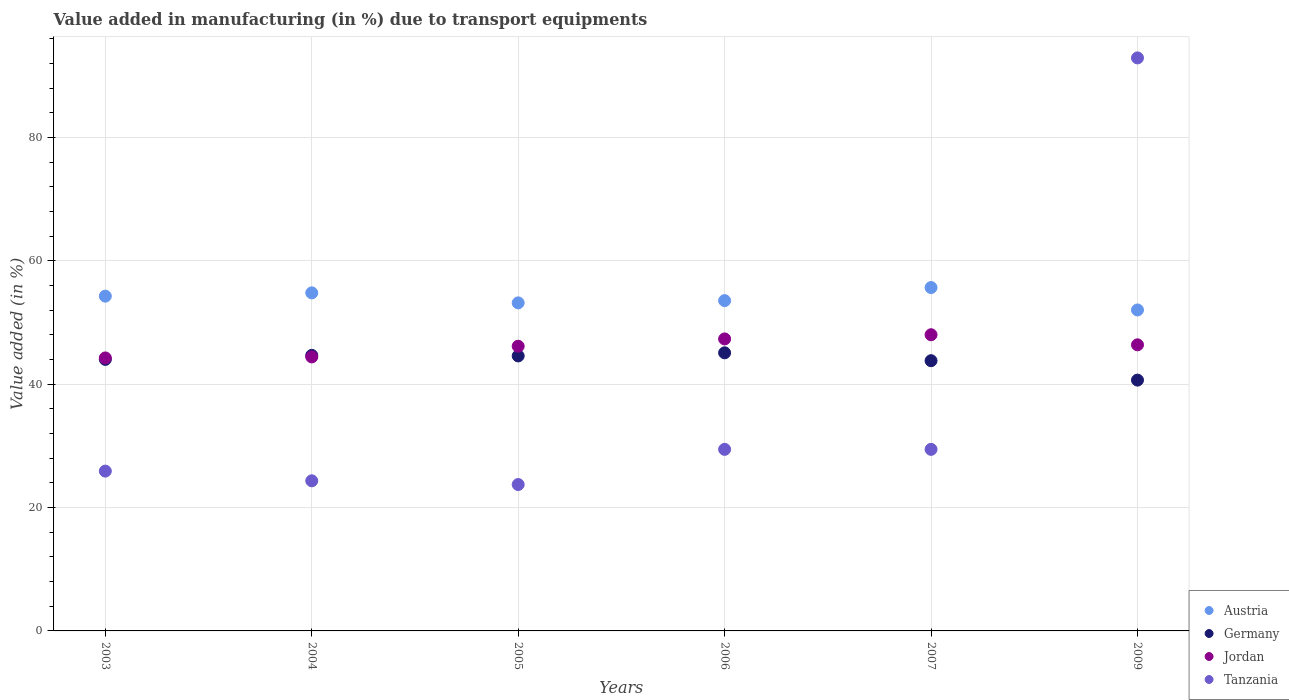What is the percentage of value added in manufacturing due to transport equipments in Germany in 2009?
Your answer should be compact. 40.67. Across all years, what is the maximum percentage of value added in manufacturing due to transport equipments in Austria?
Keep it short and to the point. 55.69. Across all years, what is the minimum percentage of value added in manufacturing due to transport equipments in Austria?
Your answer should be very brief. 52.05. What is the total percentage of value added in manufacturing due to transport equipments in Germany in the graph?
Keep it short and to the point. 262.91. What is the difference between the percentage of value added in manufacturing due to transport equipments in Jordan in 2007 and that in 2009?
Your answer should be very brief. 1.63. What is the difference between the percentage of value added in manufacturing due to transport equipments in Tanzania in 2006 and the percentage of value added in manufacturing due to transport equipments in Germany in 2004?
Provide a succinct answer. -15.24. What is the average percentage of value added in manufacturing due to transport equipments in Austria per year?
Make the answer very short. 53.94. In the year 2006, what is the difference between the percentage of value added in manufacturing due to transport equipments in Germany and percentage of value added in manufacturing due to transport equipments in Tanzania?
Give a very brief answer. 15.66. In how many years, is the percentage of value added in manufacturing due to transport equipments in Germany greater than 84 %?
Ensure brevity in your answer.  0. What is the ratio of the percentage of value added in manufacturing due to transport equipments in Jordan in 2005 to that in 2009?
Provide a succinct answer. 1. Is the percentage of value added in manufacturing due to transport equipments in Jordan in 2003 less than that in 2004?
Provide a succinct answer. Yes. What is the difference between the highest and the second highest percentage of value added in manufacturing due to transport equipments in Tanzania?
Make the answer very short. 63.48. What is the difference between the highest and the lowest percentage of value added in manufacturing due to transport equipments in Tanzania?
Provide a short and direct response. 69.19. Is the percentage of value added in manufacturing due to transport equipments in Tanzania strictly greater than the percentage of value added in manufacturing due to transport equipments in Jordan over the years?
Provide a short and direct response. No. Is the percentage of value added in manufacturing due to transport equipments in Jordan strictly less than the percentage of value added in manufacturing due to transport equipments in Austria over the years?
Your answer should be compact. Yes. How many dotlines are there?
Provide a short and direct response. 4. What is the difference between two consecutive major ticks on the Y-axis?
Your answer should be very brief. 20. Does the graph contain any zero values?
Offer a terse response. No. Does the graph contain grids?
Provide a succinct answer. Yes. Where does the legend appear in the graph?
Offer a very short reply. Bottom right. How are the legend labels stacked?
Make the answer very short. Vertical. What is the title of the graph?
Offer a terse response. Value added in manufacturing (in %) due to transport equipments. Does "Panama" appear as one of the legend labels in the graph?
Make the answer very short. No. What is the label or title of the X-axis?
Keep it short and to the point. Years. What is the label or title of the Y-axis?
Your answer should be very brief. Value added (in %). What is the Value added (in %) of Austria in 2003?
Offer a terse response. 54.29. What is the Value added (in %) of Germany in 2003?
Your answer should be very brief. 44.03. What is the Value added (in %) in Jordan in 2003?
Your answer should be very brief. 44.27. What is the Value added (in %) in Tanzania in 2003?
Keep it short and to the point. 25.92. What is the Value added (in %) of Austria in 2004?
Provide a succinct answer. 54.82. What is the Value added (in %) of Germany in 2004?
Provide a succinct answer. 44.69. What is the Value added (in %) in Jordan in 2004?
Ensure brevity in your answer.  44.44. What is the Value added (in %) in Tanzania in 2004?
Ensure brevity in your answer.  24.34. What is the Value added (in %) in Austria in 2005?
Your response must be concise. 53.2. What is the Value added (in %) of Germany in 2005?
Offer a very short reply. 44.6. What is the Value added (in %) in Jordan in 2005?
Your response must be concise. 46.17. What is the Value added (in %) of Tanzania in 2005?
Make the answer very short. 23.74. What is the Value added (in %) in Austria in 2006?
Your answer should be very brief. 53.56. What is the Value added (in %) of Germany in 2006?
Your answer should be compact. 45.1. What is the Value added (in %) of Jordan in 2006?
Your answer should be compact. 47.35. What is the Value added (in %) of Tanzania in 2006?
Offer a terse response. 29.44. What is the Value added (in %) of Austria in 2007?
Your answer should be very brief. 55.69. What is the Value added (in %) in Germany in 2007?
Offer a very short reply. 43.82. What is the Value added (in %) of Jordan in 2007?
Your response must be concise. 48.03. What is the Value added (in %) in Tanzania in 2007?
Offer a very short reply. 29.44. What is the Value added (in %) of Austria in 2009?
Offer a terse response. 52.05. What is the Value added (in %) in Germany in 2009?
Provide a short and direct response. 40.67. What is the Value added (in %) in Jordan in 2009?
Your answer should be compact. 46.4. What is the Value added (in %) in Tanzania in 2009?
Your answer should be very brief. 92.93. Across all years, what is the maximum Value added (in %) of Austria?
Your answer should be compact. 55.69. Across all years, what is the maximum Value added (in %) of Germany?
Offer a very short reply. 45.1. Across all years, what is the maximum Value added (in %) of Jordan?
Offer a terse response. 48.03. Across all years, what is the maximum Value added (in %) of Tanzania?
Give a very brief answer. 92.93. Across all years, what is the minimum Value added (in %) in Austria?
Your answer should be very brief. 52.05. Across all years, what is the minimum Value added (in %) of Germany?
Your response must be concise. 40.67. Across all years, what is the minimum Value added (in %) of Jordan?
Your response must be concise. 44.27. Across all years, what is the minimum Value added (in %) of Tanzania?
Provide a short and direct response. 23.74. What is the total Value added (in %) in Austria in the graph?
Make the answer very short. 323.61. What is the total Value added (in %) in Germany in the graph?
Offer a terse response. 262.91. What is the total Value added (in %) in Jordan in the graph?
Provide a succinct answer. 276.66. What is the total Value added (in %) in Tanzania in the graph?
Your answer should be very brief. 225.82. What is the difference between the Value added (in %) of Austria in 2003 and that in 2004?
Make the answer very short. -0.53. What is the difference between the Value added (in %) of Germany in 2003 and that in 2004?
Keep it short and to the point. -0.65. What is the difference between the Value added (in %) in Jordan in 2003 and that in 2004?
Offer a terse response. -0.17. What is the difference between the Value added (in %) of Tanzania in 2003 and that in 2004?
Ensure brevity in your answer.  1.57. What is the difference between the Value added (in %) in Austria in 2003 and that in 2005?
Give a very brief answer. 1.09. What is the difference between the Value added (in %) of Germany in 2003 and that in 2005?
Make the answer very short. -0.56. What is the difference between the Value added (in %) of Jordan in 2003 and that in 2005?
Ensure brevity in your answer.  -1.9. What is the difference between the Value added (in %) in Tanzania in 2003 and that in 2005?
Offer a very short reply. 2.18. What is the difference between the Value added (in %) of Austria in 2003 and that in 2006?
Ensure brevity in your answer.  0.73. What is the difference between the Value added (in %) in Germany in 2003 and that in 2006?
Offer a terse response. -1.07. What is the difference between the Value added (in %) in Jordan in 2003 and that in 2006?
Make the answer very short. -3.08. What is the difference between the Value added (in %) of Tanzania in 2003 and that in 2006?
Offer a terse response. -3.53. What is the difference between the Value added (in %) of Austria in 2003 and that in 2007?
Provide a succinct answer. -1.4. What is the difference between the Value added (in %) in Germany in 2003 and that in 2007?
Offer a terse response. 0.21. What is the difference between the Value added (in %) of Jordan in 2003 and that in 2007?
Your answer should be very brief. -3.76. What is the difference between the Value added (in %) of Tanzania in 2003 and that in 2007?
Provide a short and direct response. -3.53. What is the difference between the Value added (in %) of Austria in 2003 and that in 2009?
Keep it short and to the point. 2.24. What is the difference between the Value added (in %) in Germany in 2003 and that in 2009?
Ensure brevity in your answer.  3.36. What is the difference between the Value added (in %) of Jordan in 2003 and that in 2009?
Offer a very short reply. -2.13. What is the difference between the Value added (in %) of Tanzania in 2003 and that in 2009?
Keep it short and to the point. -67.01. What is the difference between the Value added (in %) in Austria in 2004 and that in 2005?
Give a very brief answer. 1.62. What is the difference between the Value added (in %) of Germany in 2004 and that in 2005?
Make the answer very short. 0.09. What is the difference between the Value added (in %) in Jordan in 2004 and that in 2005?
Your answer should be compact. -1.73. What is the difference between the Value added (in %) of Tanzania in 2004 and that in 2005?
Offer a very short reply. 0.61. What is the difference between the Value added (in %) in Austria in 2004 and that in 2006?
Your answer should be compact. 1.26. What is the difference between the Value added (in %) of Germany in 2004 and that in 2006?
Make the answer very short. -0.41. What is the difference between the Value added (in %) of Jordan in 2004 and that in 2006?
Offer a terse response. -2.92. What is the difference between the Value added (in %) in Austria in 2004 and that in 2007?
Your answer should be compact. -0.86. What is the difference between the Value added (in %) of Germany in 2004 and that in 2007?
Ensure brevity in your answer.  0.87. What is the difference between the Value added (in %) of Jordan in 2004 and that in 2007?
Provide a succinct answer. -3.6. What is the difference between the Value added (in %) in Tanzania in 2004 and that in 2007?
Provide a succinct answer. -5.1. What is the difference between the Value added (in %) in Austria in 2004 and that in 2009?
Provide a succinct answer. 2.77. What is the difference between the Value added (in %) of Germany in 2004 and that in 2009?
Give a very brief answer. 4.01. What is the difference between the Value added (in %) of Jordan in 2004 and that in 2009?
Keep it short and to the point. -1.96. What is the difference between the Value added (in %) in Tanzania in 2004 and that in 2009?
Make the answer very short. -68.58. What is the difference between the Value added (in %) of Austria in 2005 and that in 2006?
Keep it short and to the point. -0.36. What is the difference between the Value added (in %) of Germany in 2005 and that in 2006?
Your answer should be very brief. -0.5. What is the difference between the Value added (in %) in Jordan in 2005 and that in 2006?
Provide a succinct answer. -1.18. What is the difference between the Value added (in %) in Tanzania in 2005 and that in 2006?
Offer a very short reply. -5.71. What is the difference between the Value added (in %) of Austria in 2005 and that in 2007?
Your response must be concise. -2.49. What is the difference between the Value added (in %) in Germany in 2005 and that in 2007?
Keep it short and to the point. 0.77. What is the difference between the Value added (in %) in Jordan in 2005 and that in 2007?
Provide a short and direct response. -1.86. What is the difference between the Value added (in %) of Tanzania in 2005 and that in 2007?
Your answer should be very brief. -5.71. What is the difference between the Value added (in %) in Austria in 2005 and that in 2009?
Your answer should be very brief. 1.15. What is the difference between the Value added (in %) in Germany in 2005 and that in 2009?
Your response must be concise. 3.92. What is the difference between the Value added (in %) in Jordan in 2005 and that in 2009?
Your response must be concise. -0.23. What is the difference between the Value added (in %) in Tanzania in 2005 and that in 2009?
Your answer should be very brief. -69.19. What is the difference between the Value added (in %) of Austria in 2006 and that in 2007?
Offer a terse response. -2.12. What is the difference between the Value added (in %) in Germany in 2006 and that in 2007?
Make the answer very short. 1.28. What is the difference between the Value added (in %) in Jordan in 2006 and that in 2007?
Keep it short and to the point. -0.68. What is the difference between the Value added (in %) in Tanzania in 2006 and that in 2007?
Keep it short and to the point. -0. What is the difference between the Value added (in %) in Austria in 2006 and that in 2009?
Provide a short and direct response. 1.51. What is the difference between the Value added (in %) of Germany in 2006 and that in 2009?
Ensure brevity in your answer.  4.43. What is the difference between the Value added (in %) of Jordan in 2006 and that in 2009?
Offer a terse response. 0.96. What is the difference between the Value added (in %) in Tanzania in 2006 and that in 2009?
Keep it short and to the point. -63.48. What is the difference between the Value added (in %) in Austria in 2007 and that in 2009?
Your response must be concise. 3.64. What is the difference between the Value added (in %) of Germany in 2007 and that in 2009?
Your answer should be very brief. 3.15. What is the difference between the Value added (in %) of Jordan in 2007 and that in 2009?
Offer a terse response. 1.63. What is the difference between the Value added (in %) in Tanzania in 2007 and that in 2009?
Provide a short and direct response. -63.48. What is the difference between the Value added (in %) in Austria in 2003 and the Value added (in %) in Germany in 2004?
Provide a short and direct response. 9.6. What is the difference between the Value added (in %) in Austria in 2003 and the Value added (in %) in Jordan in 2004?
Keep it short and to the point. 9.85. What is the difference between the Value added (in %) of Austria in 2003 and the Value added (in %) of Tanzania in 2004?
Offer a terse response. 29.95. What is the difference between the Value added (in %) in Germany in 2003 and the Value added (in %) in Jordan in 2004?
Ensure brevity in your answer.  -0.4. What is the difference between the Value added (in %) of Germany in 2003 and the Value added (in %) of Tanzania in 2004?
Offer a terse response. 19.69. What is the difference between the Value added (in %) in Jordan in 2003 and the Value added (in %) in Tanzania in 2004?
Your answer should be very brief. 19.93. What is the difference between the Value added (in %) of Austria in 2003 and the Value added (in %) of Germany in 2005?
Ensure brevity in your answer.  9.69. What is the difference between the Value added (in %) in Austria in 2003 and the Value added (in %) in Jordan in 2005?
Offer a terse response. 8.12. What is the difference between the Value added (in %) in Austria in 2003 and the Value added (in %) in Tanzania in 2005?
Provide a succinct answer. 30.55. What is the difference between the Value added (in %) in Germany in 2003 and the Value added (in %) in Jordan in 2005?
Keep it short and to the point. -2.14. What is the difference between the Value added (in %) of Germany in 2003 and the Value added (in %) of Tanzania in 2005?
Your answer should be very brief. 20.29. What is the difference between the Value added (in %) of Jordan in 2003 and the Value added (in %) of Tanzania in 2005?
Ensure brevity in your answer.  20.53. What is the difference between the Value added (in %) of Austria in 2003 and the Value added (in %) of Germany in 2006?
Your answer should be very brief. 9.19. What is the difference between the Value added (in %) in Austria in 2003 and the Value added (in %) in Jordan in 2006?
Make the answer very short. 6.94. What is the difference between the Value added (in %) in Austria in 2003 and the Value added (in %) in Tanzania in 2006?
Ensure brevity in your answer.  24.85. What is the difference between the Value added (in %) in Germany in 2003 and the Value added (in %) in Jordan in 2006?
Offer a terse response. -3.32. What is the difference between the Value added (in %) in Germany in 2003 and the Value added (in %) in Tanzania in 2006?
Provide a short and direct response. 14.59. What is the difference between the Value added (in %) of Jordan in 2003 and the Value added (in %) of Tanzania in 2006?
Offer a very short reply. 14.83. What is the difference between the Value added (in %) of Austria in 2003 and the Value added (in %) of Germany in 2007?
Make the answer very short. 10.47. What is the difference between the Value added (in %) of Austria in 2003 and the Value added (in %) of Jordan in 2007?
Your answer should be compact. 6.26. What is the difference between the Value added (in %) in Austria in 2003 and the Value added (in %) in Tanzania in 2007?
Ensure brevity in your answer.  24.85. What is the difference between the Value added (in %) in Germany in 2003 and the Value added (in %) in Jordan in 2007?
Provide a succinct answer. -4. What is the difference between the Value added (in %) of Germany in 2003 and the Value added (in %) of Tanzania in 2007?
Your response must be concise. 14.59. What is the difference between the Value added (in %) in Jordan in 2003 and the Value added (in %) in Tanzania in 2007?
Your response must be concise. 14.83. What is the difference between the Value added (in %) in Austria in 2003 and the Value added (in %) in Germany in 2009?
Provide a succinct answer. 13.62. What is the difference between the Value added (in %) in Austria in 2003 and the Value added (in %) in Jordan in 2009?
Give a very brief answer. 7.89. What is the difference between the Value added (in %) of Austria in 2003 and the Value added (in %) of Tanzania in 2009?
Provide a succinct answer. -38.64. What is the difference between the Value added (in %) of Germany in 2003 and the Value added (in %) of Jordan in 2009?
Offer a terse response. -2.36. What is the difference between the Value added (in %) of Germany in 2003 and the Value added (in %) of Tanzania in 2009?
Your answer should be very brief. -48.89. What is the difference between the Value added (in %) of Jordan in 2003 and the Value added (in %) of Tanzania in 2009?
Give a very brief answer. -48.66. What is the difference between the Value added (in %) of Austria in 2004 and the Value added (in %) of Germany in 2005?
Make the answer very short. 10.23. What is the difference between the Value added (in %) in Austria in 2004 and the Value added (in %) in Jordan in 2005?
Offer a very short reply. 8.65. What is the difference between the Value added (in %) of Austria in 2004 and the Value added (in %) of Tanzania in 2005?
Offer a very short reply. 31.08. What is the difference between the Value added (in %) of Germany in 2004 and the Value added (in %) of Jordan in 2005?
Your response must be concise. -1.48. What is the difference between the Value added (in %) in Germany in 2004 and the Value added (in %) in Tanzania in 2005?
Your response must be concise. 20.95. What is the difference between the Value added (in %) of Jordan in 2004 and the Value added (in %) of Tanzania in 2005?
Make the answer very short. 20.7. What is the difference between the Value added (in %) in Austria in 2004 and the Value added (in %) in Germany in 2006?
Give a very brief answer. 9.72. What is the difference between the Value added (in %) of Austria in 2004 and the Value added (in %) of Jordan in 2006?
Your answer should be compact. 7.47. What is the difference between the Value added (in %) in Austria in 2004 and the Value added (in %) in Tanzania in 2006?
Your answer should be compact. 25.38. What is the difference between the Value added (in %) in Germany in 2004 and the Value added (in %) in Jordan in 2006?
Provide a succinct answer. -2.67. What is the difference between the Value added (in %) of Germany in 2004 and the Value added (in %) of Tanzania in 2006?
Give a very brief answer. 15.24. What is the difference between the Value added (in %) of Jordan in 2004 and the Value added (in %) of Tanzania in 2006?
Ensure brevity in your answer.  14.99. What is the difference between the Value added (in %) in Austria in 2004 and the Value added (in %) in Germany in 2007?
Offer a very short reply. 11. What is the difference between the Value added (in %) of Austria in 2004 and the Value added (in %) of Jordan in 2007?
Offer a terse response. 6.79. What is the difference between the Value added (in %) of Austria in 2004 and the Value added (in %) of Tanzania in 2007?
Offer a very short reply. 25.38. What is the difference between the Value added (in %) in Germany in 2004 and the Value added (in %) in Jordan in 2007?
Make the answer very short. -3.34. What is the difference between the Value added (in %) in Germany in 2004 and the Value added (in %) in Tanzania in 2007?
Keep it short and to the point. 15.24. What is the difference between the Value added (in %) in Jordan in 2004 and the Value added (in %) in Tanzania in 2007?
Offer a terse response. 14.99. What is the difference between the Value added (in %) of Austria in 2004 and the Value added (in %) of Germany in 2009?
Provide a succinct answer. 14.15. What is the difference between the Value added (in %) of Austria in 2004 and the Value added (in %) of Jordan in 2009?
Make the answer very short. 8.42. What is the difference between the Value added (in %) in Austria in 2004 and the Value added (in %) in Tanzania in 2009?
Your answer should be very brief. -38.1. What is the difference between the Value added (in %) of Germany in 2004 and the Value added (in %) of Jordan in 2009?
Give a very brief answer. -1.71. What is the difference between the Value added (in %) in Germany in 2004 and the Value added (in %) in Tanzania in 2009?
Your response must be concise. -48.24. What is the difference between the Value added (in %) in Jordan in 2004 and the Value added (in %) in Tanzania in 2009?
Ensure brevity in your answer.  -48.49. What is the difference between the Value added (in %) in Austria in 2005 and the Value added (in %) in Germany in 2006?
Ensure brevity in your answer.  8.1. What is the difference between the Value added (in %) of Austria in 2005 and the Value added (in %) of Jordan in 2006?
Your response must be concise. 5.85. What is the difference between the Value added (in %) in Austria in 2005 and the Value added (in %) in Tanzania in 2006?
Keep it short and to the point. 23.76. What is the difference between the Value added (in %) in Germany in 2005 and the Value added (in %) in Jordan in 2006?
Your answer should be very brief. -2.76. What is the difference between the Value added (in %) of Germany in 2005 and the Value added (in %) of Tanzania in 2006?
Offer a very short reply. 15.15. What is the difference between the Value added (in %) in Jordan in 2005 and the Value added (in %) in Tanzania in 2006?
Keep it short and to the point. 16.72. What is the difference between the Value added (in %) in Austria in 2005 and the Value added (in %) in Germany in 2007?
Your answer should be very brief. 9.38. What is the difference between the Value added (in %) of Austria in 2005 and the Value added (in %) of Jordan in 2007?
Offer a very short reply. 5.17. What is the difference between the Value added (in %) in Austria in 2005 and the Value added (in %) in Tanzania in 2007?
Offer a terse response. 23.76. What is the difference between the Value added (in %) in Germany in 2005 and the Value added (in %) in Jordan in 2007?
Provide a short and direct response. -3.44. What is the difference between the Value added (in %) of Germany in 2005 and the Value added (in %) of Tanzania in 2007?
Give a very brief answer. 15.15. What is the difference between the Value added (in %) in Jordan in 2005 and the Value added (in %) in Tanzania in 2007?
Offer a very short reply. 16.72. What is the difference between the Value added (in %) in Austria in 2005 and the Value added (in %) in Germany in 2009?
Provide a succinct answer. 12.53. What is the difference between the Value added (in %) of Austria in 2005 and the Value added (in %) of Jordan in 2009?
Give a very brief answer. 6.8. What is the difference between the Value added (in %) of Austria in 2005 and the Value added (in %) of Tanzania in 2009?
Your answer should be very brief. -39.72. What is the difference between the Value added (in %) of Germany in 2005 and the Value added (in %) of Jordan in 2009?
Your answer should be compact. -1.8. What is the difference between the Value added (in %) of Germany in 2005 and the Value added (in %) of Tanzania in 2009?
Make the answer very short. -48.33. What is the difference between the Value added (in %) of Jordan in 2005 and the Value added (in %) of Tanzania in 2009?
Provide a short and direct response. -46.76. What is the difference between the Value added (in %) of Austria in 2006 and the Value added (in %) of Germany in 2007?
Keep it short and to the point. 9.74. What is the difference between the Value added (in %) in Austria in 2006 and the Value added (in %) in Jordan in 2007?
Provide a short and direct response. 5.53. What is the difference between the Value added (in %) of Austria in 2006 and the Value added (in %) of Tanzania in 2007?
Provide a short and direct response. 24.12. What is the difference between the Value added (in %) of Germany in 2006 and the Value added (in %) of Jordan in 2007?
Give a very brief answer. -2.93. What is the difference between the Value added (in %) of Germany in 2006 and the Value added (in %) of Tanzania in 2007?
Provide a short and direct response. 15.66. What is the difference between the Value added (in %) in Jordan in 2006 and the Value added (in %) in Tanzania in 2007?
Provide a short and direct response. 17.91. What is the difference between the Value added (in %) in Austria in 2006 and the Value added (in %) in Germany in 2009?
Provide a succinct answer. 12.89. What is the difference between the Value added (in %) of Austria in 2006 and the Value added (in %) of Jordan in 2009?
Offer a very short reply. 7.17. What is the difference between the Value added (in %) of Austria in 2006 and the Value added (in %) of Tanzania in 2009?
Provide a succinct answer. -39.36. What is the difference between the Value added (in %) of Germany in 2006 and the Value added (in %) of Jordan in 2009?
Offer a very short reply. -1.3. What is the difference between the Value added (in %) in Germany in 2006 and the Value added (in %) in Tanzania in 2009?
Your answer should be very brief. -47.83. What is the difference between the Value added (in %) of Jordan in 2006 and the Value added (in %) of Tanzania in 2009?
Offer a terse response. -45.57. What is the difference between the Value added (in %) of Austria in 2007 and the Value added (in %) of Germany in 2009?
Offer a terse response. 15.01. What is the difference between the Value added (in %) of Austria in 2007 and the Value added (in %) of Jordan in 2009?
Give a very brief answer. 9.29. What is the difference between the Value added (in %) of Austria in 2007 and the Value added (in %) of Tanzania in 2009?
Give a very brief answer. -37.24. What is the difference between the Value added (in %) of Germany in 2007 and the Value added (in %) of Jordan in 2009?
Offer a very short reply. -2.58. What is the difference between the Value added (in %) of Germany in 2007 and the Value added (in %) of Tanzania in 2009?
Make the answer very short. -49.1. What is the difference between the Value added (in %) in Jordan in 2007 and the Value added (in %) in Tanzania in 2009?
Ensure brevity in your answer.  -44.89. What is the average Value added (in %) in Austria per year?
Ensure brevity in your answer.  53.94. What is the average Value added (in %) of Germany per year?
Provide a short and direct response. 43.82. What is the average Value added (in %) in Jordan per year?
Offer a very short reply. 46.11. What is the average Value added (in %) of Tanzania per year?
Provide a short and direct response. 37.64. In the year 2003, what is the difference between the Value added (in %) in Austria and Value added (in %) in Germany?
Make the answer very short. 10.26. In the year 2003, what is the difference between the Value added (in %) in Austria and Value added (in %) in Jordan?
Make the answer very short. 10.02. In the year 2003, what is the difference between the Value added (in %) of Austria and Value added (in %) of Tanzania?
Your answer should be very brief. 28.37. In the year 2003, what is the difference between the Value added (in %) of Germany and Value added (in %) of Jordan?
Offer a very short reply. -0.24. In the year 2003, what is the difference between the Value added (in %) in Germany and Value added (in %) in Tanzania?
Give a very brief answer. 18.11. In the year 2003, what is the difference between the Value added (in %) in Jordan and Value added (in %) in Tanzania?
Ensure brevity in your answer.  18.35. In the year 2004, what is the difference between the Value added (in %) of Austria and Value added (in %) of Germany?
Provide a succinct answer. 10.13. In the year 2004, what is the difference between the Value added (in %) of Austria and Value added (in %) of Jordan?
Keep it short and to the point. 10.39. In the year 2004, what is the difference between the Value added (in %) in Austria and Value added (in %) in Tanzania?
Offer a very short reply. 30.48. In the year 2004, what is the difference between the Value added (in %) in Germany and Value added (in %) in Jordan?
Ensure brevity in your answer.  0.25. In the year 2004, what is the difference between the Value added (in %) in Germany and Value added (in %) in Tanzania?
Offer a terse response. 20.34. In the year 2004, what is the difference between the Value added (in %) of Jordan and Value added (in %) of Tanzania?
Your answer should be very brief. 20.09. In the year 2005, what is the difference between the Value added (in %) in Austria and Value added (in %) in Germany?
Your answer should be compact. 8.61. In the year 2005, what is the difference between the Value added (in %) of Austria and Value added (in %) of Jordan?
Your response must be concise. 7.03. In the year 2005, what is the difference between the Value added (in %) in Austria and Value added (in %) in Tanzania?
Offer a terse response. 29.46. In the year 2005, what is the difference between the Value added (in %) of Germany and Value added (in %) of Jordan?
Offer a terse response. -1.57. In the year 2005, what is the difference between the Value added (in %) of Germany and Value added (in %) of Tanzania?
Make the answer very short. 20.86. In the year 2005, what is the difference between the Value added (in %) in Jordan and Value added (in %) in Tanzania?
Provide a short and direct response. 22.43. In the year 2006, what is the difference between the Value added (in %) in Austria and Value added (in %) in Germany?
Give a very brief answer. 8.47. In the year 2006, what is the difference between the Value added (in %) of Austria and Value added (in %) of Jordan?
Offer a very short reply. 6.21. In the year 2006, what is the difference between the Value added (in %) of Austria and Value added (in %) of Tanzania?
Offer a very short reply. 24.12. In the year 2006, what is the difference between the Value added (in %) in Germany and Value added (in %) in Jordan?
Provide a succinct answer. -2.25. In the year 2006, what is the difference between the Value added (in %) of Germany and Value added (in %) of Tanzania?
Keep it short and to the point. 15.66. In the year 2006, what is the difference between the Value added (in %) of Jordan and Value added (in %) of Tanzania?
Ensure brevity in your answer.  17.91. In the year 2007, what is the difference between the Value added (in %) of Austria and Value added (in %) of Germany?
Make the answer very short. 11.86. In the year 2007, what is the difference between the Value added (in %) of Austria and Value added (in %) of Jordan?
Your response must be concise. 7.65. In the year 2007, what is the difference between the Value added (in %) of Austria and Value added (in %) of Tanzania?
Your answer should be very brief. 26.24. In the year 2007, what is the difference between the Value added (in %) of Germany and Value added (in %) of Jordan?
Your answer should be very brief. -4.21. In the year 2007, what is the difference between the Value added (in %) of Germany and Value added (in %) of Tanzania?
Your answer should be compact. 14.38. In the year 2007, what is the difference between the Value added (in %) of Jordan and Value added (in %) of Tanzania?
Your response must be concise. 18.59. In the year 2009, what is the difference between the Value added (in %) in Austria and Value added (in %) in Germany?
Your answer should be compact. 11.38. In the year 2009, what is the difference between the Value added (in %) of Austria and Value added (in %) of Jordan?
Your answer should be compact. 5.65. In the year 2009, what is the difference between the Value added (in %) of Austria and Value added (in %) of Tanzania?
Your answer should be very brief. -40.88. In the year 2009, what is the difference between the Value added (in %) in Germany and Value added (in %) in Jordan?
Offer a terse response. -5.72. In the year 2009, what is the difference between the Value added (in %) of Germany and Value added (in %) of Tanzania?
Your response must be concise. -52.25. In the year 2009, what is the difference between the Value added (in %) of Jordan and Value added (in %) of Tanzania?
Keep it short and to the point. -46.53. What is the ratio of the Value added (in %) of Austria in 2003 to that in 2004?
Offer a very short reply. 0.99. What is the ratio of the Value added (in %) of Germany in 2003 to that in 2004?
Your answer should be very brief. 0.99. What is the ratio of the Value added (in %) in Tanzania in 2003 to that in 2004?
Give a very brief answer. 1.06. What is the ratio of the Value added (in %) of Austria in 2003 to that in 2005?
Your answer should be compact. 1.02. What is the ratio of the Value added (in %) in Germany in 2003 to that in 2005?
Provide a succinct answer. 0.99. What is the ratio of the Value added (in %) in Jordan in 2003 to that in 2005?
Keep it short and to the point. 0.96. What is the ratio of the Value added (in %) of Tanzania in 2003 to that in 2005?
Offer a very short reply. 1.09. What is the ratio of the Value added (in %) of Austria in 2003 to that in 2006?
Keep it short and to the point. 1.01. What is the ratio of the Value added (in %) of Germany in 2003 to that in 2006?
Your answer should be compact. 0.98. What is the ratio of the Value added (in %) in Jordan in 2003 to that in 2006?
Give a very brief answer. 0.93. What is the ratio of the Value added (in %) of Tanzania in 2003 to that in 2006?
Provide a succinct answer. 0.88. What is the ratio of the Value added (in %) of Austria in 2003 to that in 2007?
Give a very brief answer. 0.97. What is the ratio of the Value added (in %) of Germany in 2003 to that in 2007?
Your response must be concise. 1. What is the ratio of the Value added (in %) in Jordan in 2003 to that in 2007?
Provide a short and direct response. 0.92. What is the ratio of the Value added (in %) of Tanzania in 2003 to that in 2007?
Provide a short and direct response. 0.88. What is the ratio of the Value added (in %) in Austria in 2003 to that in 2009?
Your answer should be compact. 1.04. What is the ratio of the Value added (in %) of Germany in 2003 to that in 2009?
Your answer should be very brief. 1.08. What is the ratio of the Value added (in %) in Jordan in 2003 to that in 2009?
Make the answer very short. 0.95. What is the ratio of the Value added (in %) of Tanzania in 2003 to that in 2009?
Ensure brevity in your answer.  0.28. What is the ratio of the Value added (in %) in Austria in 2004 to that in 2005?
Your response must be concise. 1.03. What is the ratio of the Value added (in %) of Germany in 2004 to that in 2005?
Keep it short and to the point. 1. What is the ratio of the Value added (in %) of Jordan in 2004 to that in 2005?
Your response must be concise. 0.96. What is the ratio of the Value added (in %) of Tanzania in 2004 to that in 2005?
Your answer should be compact. 1.03. What is the ratio of the Value added (in %) of Austria in 2004 to that in 2006?
Provide a succinct answer. 1.02. What is the ratio of the Value added (in %) in Germany in 2004 to that in 2006?
Provide a short and direct response. 0.99. What is the ratio of the Value added (in %) in Jordan in 2004 to that in 2006?
Offer a very short reply. 0.94. What is the ratio of the Value added (in %) in Tanzania in 2004 to that in 2006?
Offer a very short reply. 0.83. What is the ratio of the Value added (in %) in Austria in 2004 to that in 2007?
Make the answer very short. 0.98. What is the ratio of the Value added (in %) in Germany in 2004 to that in 2007?
Make the answer very short. 1.02. What is the ratio of the Value added (in %) in Jordan in 2004 to that in 2007?
Your answer should be compact. 0.93. What is the ratio of the Value added (in %) in Tanzania in 2004 to that in 2007?
Offer a terse response. 0.83. What is the ratio of the Value added (in %) in Austria in 2004 to that in 2009?
Make the answer very short. 1.05. What is the ratio of the Value added (in %) of Germany in 2004 to that in 2009?
Offer a terse response. 1.1. What is the ratio of the Value added (in %) in Jordan in 2004 to that in 2009?
Offer a very short reply. 0.96. What is the ratio of the Value added (in %) in Tanzania in 2004 to that in 2009?
Make the answer very short. 0.26. What is the ratio of the Value added (in %) of Austria in 2005 to that in 2006?
Provide a short and direct response. 0.99. What is the ratio of the Value added (in %) in Tanzania in 2005 to that in 2006?
Make the answer very short. 0.81. What is the ratio of the Value added (in %) of Austria in 2005 to that in 2007?
Offer a very short reply. 0.96. What is the ratio of the Value added (in %) of Germany in 2005 to that in 2007?
Your answer should be very brief. 1.02. What is the ratio of the Value added (in %) in Jordan in 2005 to that in 2007?
Make the answer very short. 0.96. What is the ratio of the Value added (in %) in Tanzania in 2005 to that in 2007?
Provide a short and direct response. 0.81. What is the ratio of the Value added (in %) of Austria in 2005 to that in 2009?
Offer a terse response. 1.02. What is the ratio of the Value added (in %) in Germany in 2005 to that in 2009?
Give a very brief answer. 1.1. What is the ratio of the Value added (in %) of Tanzania in 2005 to that in 2009?
Give a very brief answer. 0.26. What is the ratio of the Value added (in %) in Austria in 2006 to that in 2007?
Make the answer very short. 0.96. What is the ratio of the Value added (in %) of Germany in 2006 to that in 2007?
Your answer should be very brief. 1.03. What is the ratio of the Value added (in %) of Jordan in 2006 to that in 2007?
Offer a very short reply. 0.99. What is the ratio of the Value added (in %) in Austria in 2006 to that in 2009?
Offer a very short reply. 1.03. What is the ratio of the Value added (in %) in Germany in 2006 to that in 2009?
Provide a succinct answer. 1.11. What is the ratio of the Value added (in %) of Jordan in 2006 to that in 2009?
Provide a succinct answer. 1.02. What is the ratio of the Value added (in %) of Tanzania in 2006 to that in 2009?
Your response must be concise. 0.32. What is the ratio of the Value added (in %) of Austria in 2007 to that in 2009?
Provide a succinct answer. 1.07. What is the ratio of the Value added (in %) of Germany in 2007 to that in 2009?
Offer a very short reply. 1.08. What is the ratio of the Value added (in %) of Jordan in 2007 to that in 2009?
Give a very brief answer. 1.04. What is the ratio of the Value added (in %) of Tanzania in 2007 to that in 2009?
Make the answer very short. 0.32. What is the difference between the highest and the second highest Value added (in %) of Austria?
Your response must be concise. 0.86. What is the difference between the highest and the second highest Value added (in %) of Germany?
Provide a short and direct response. 0.41. What is the difference between the highest and the second highest Value added (in %) of Jordan?
Ensure brevity in your answer.  0.68. What is the difference between the highest and the second highest Value added (in %) of Tanzania?
Your answer should be very brief. 63.48. What is the difference between the highest and the lowest Value added (in %) in Austria?
Make the answer very short. 3.64. What is the difference between the highest and the lowest Value added (in %) in Germany?
Your answer should be compact. 4.43. What is the difference between the highest and the lowest Value added (in %) in Jordan?
Ensure brevity in your answer.  3.76. What is the difference between the highest and the lowest Value added (in %) of Tanzania?
Keep it short and to the point. 69.19. 